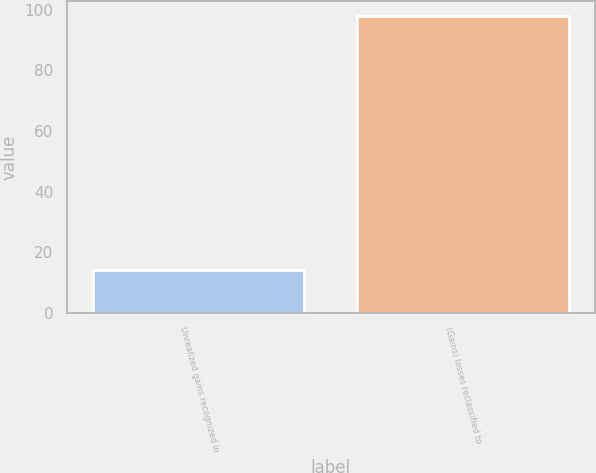<chart> <loc_0><loc_0><loc_500><loc_500><bar_chart><fcel>Unrealized gains recognized in<fcel>(Gains) losses reclassified to<nl><fcel>14<fcel>98<nl></chart> 